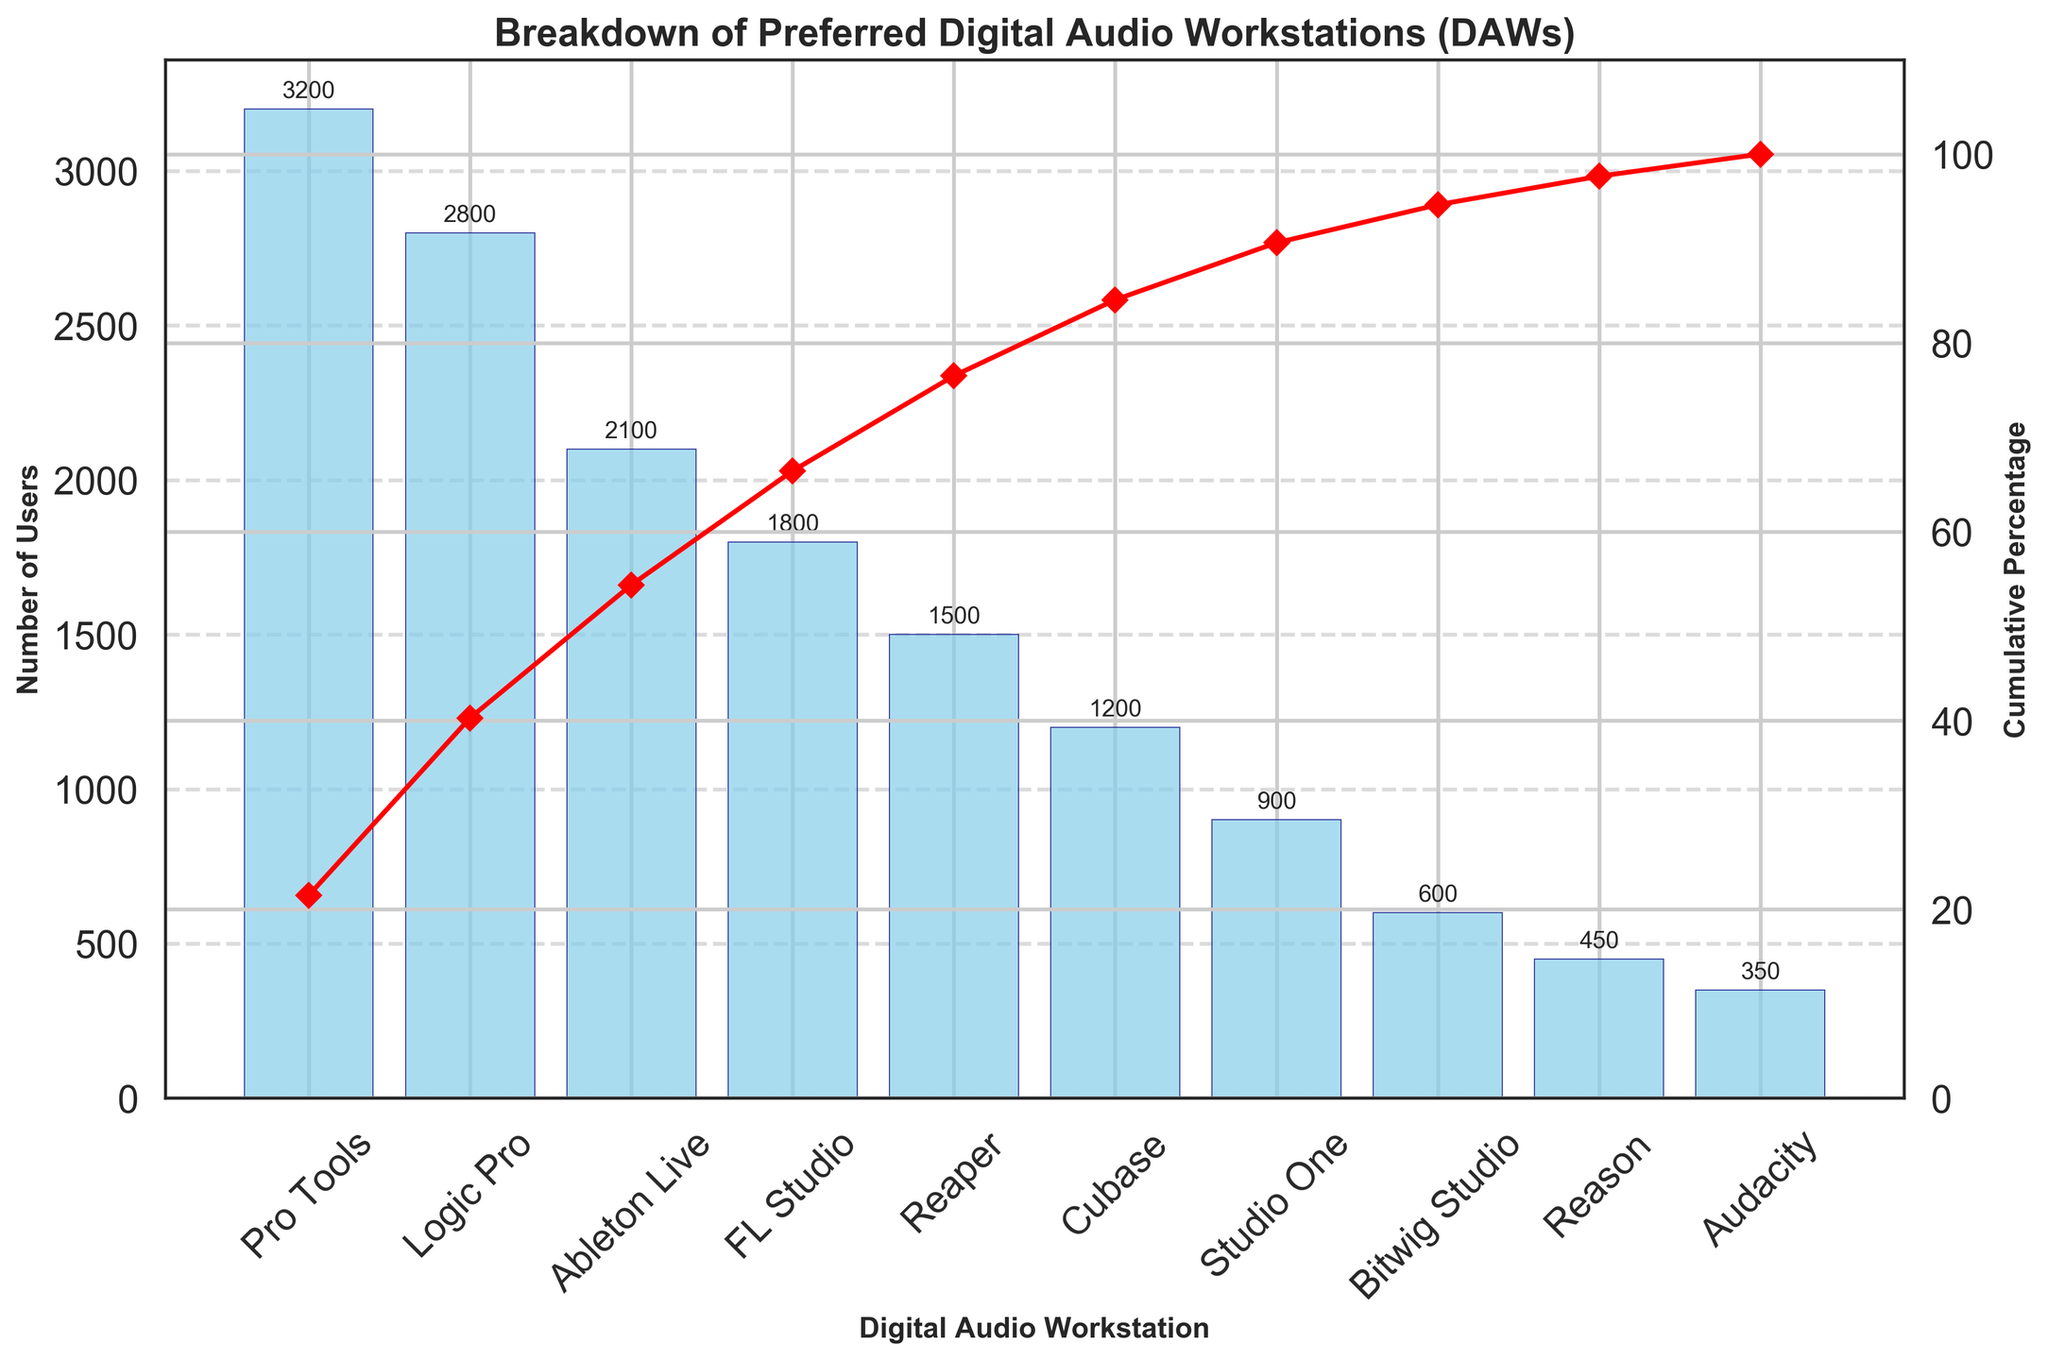Which DAW has the highest number of users? Observe the height of the bars to identify the tallest one, which corresponds to the DAW with the highest number of users. Pro Tools is the highest with 3200 users.
Answer: Pro Tools What percentage of users prefer Pro Tools? Reference the cumulative percentage line plot at the position of the Pro Tools bar. The cumulative percentage for Pro Tools matches its usage percentage directly since it's the first bar.
Answer: Approximately 20.4% Which DAWs make up approximately 50% of the total user base? Sum the number of users from the top until reaching close to 50%. Pro Tools (3200) + Logic Pro (2800) + Ableton Live (2100) = 8100, which is more than half of the total of 15000.
Answer: Pro Tools, Logic Pro, and Ableton Live What is the cumulative percentage for FL Studio users? Trace the cumulative percentage line plot to the point marked for FL Studio. The line plot should indicate the approximate cumulative contribution including all bars up to FL Studio.
Answer: Approximately 67.3% How many users prefer DAWs other than Pro Tools, Logic Pro, and Ableton Live? Subtract the sum of users of Pro Tools, Logic Pro, and Ableton Live from the total number of users. 15000 - (3200 + 2800 + 2100) = 6900.
Answer: 6900 Compare the number of users for Reaper and Cubase. Which one is more popular? Compare the heights of the bars representing Reaper and Cubase. Reaper has a bar of 1500 users, while Cubase has 1200.
Answer: Reaper At what point does the cumulative percentage cross 80%? Trace the cumulative percentage line upwards until it crosses 80% and identify the corresponding DAW. This happens at or right after the Studio One bar.
Answer: Studio One Which DAWs are used by fewer than 1000 users? Identify bars shorter than the 1000 user mark. DAWs meeting this criteria are Studio One, Bitwig Studio, Reason, and Audacity.
Answer: Studio One, Bitwig Studio, Reason, and Audacity What is the difference in user numbers between the least and most preferred DAWs? Subtract the users of the least preferred DAW (Audacity with 350 users) from those of the most preferred DAW (Pro Tools with 3200 users). 3200 - 350 = 2850.
Answer: 2850 How many DAWs combined account for about 90% of the total user base? Follow the cumulative percentage line until you reach 90%, then count the bars up to that point. This includes bars up to Reason.
Answer: 8 